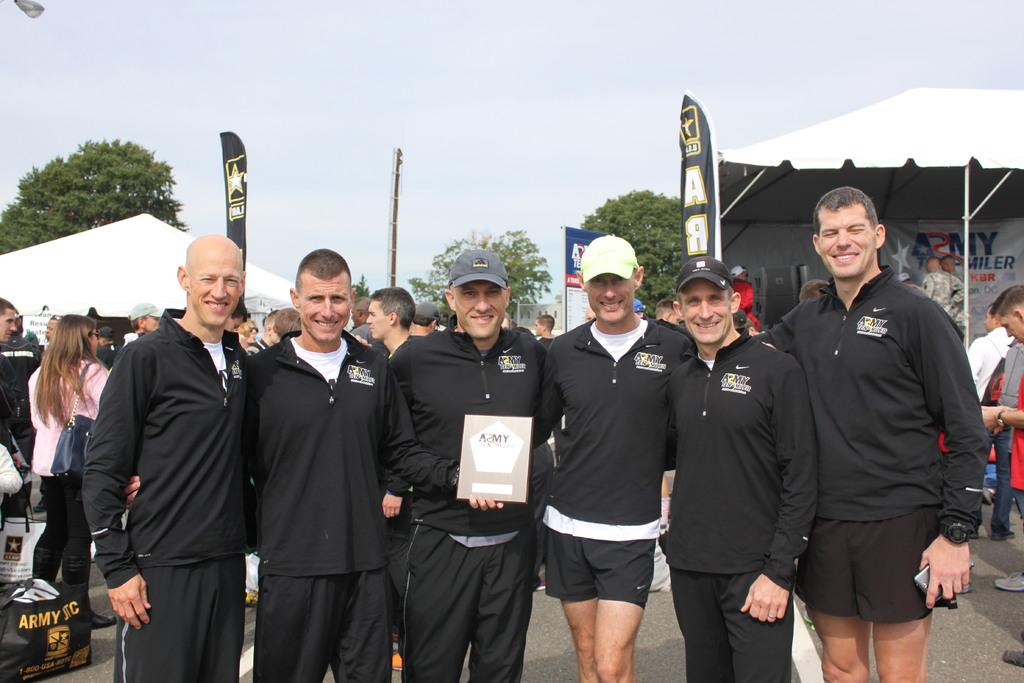What is happening in the center of the image? There is a group of persons on the road in the center of the image. Can you describe the background of the image? There are persons, tents, advertisements, trees, and the sky visible in the background. How many groups of persons can be seen in the image? There is one group of persons in the center of the image, and there are also persons visible in the background. What type of structures are present in the background? Tents are present in the background. What type of eggs can be seen in the image? There are no eggs present in the image. What part of the pickle is visible in the image? There is no pickle present in the image. 